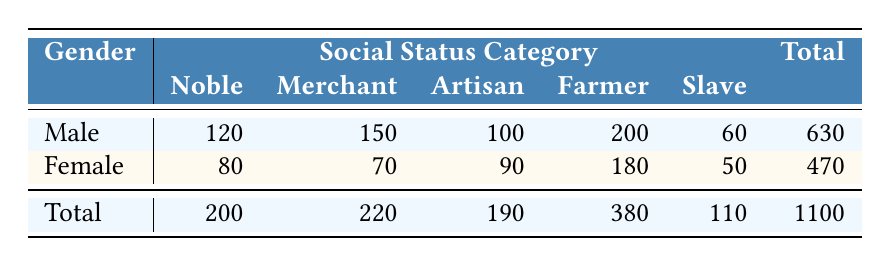What is the total count of nobles by gender? The table shows that there are 120 nobles who are male and 80 nobles who are female. Therefore, to find the total count of nobles, we sum these values: 120 + 80 = 200.
Answer: 200 How many male artisans are there compared to females? The table indicates that there are 100 male artisans and 90 female artisans. To find the difference, subtract the number of female artisans from male artisans: 100 - 90 = 10.
Answer: 10 What is the total count of farmers in the data? The table lists 200 male farmers and 180 female farmers. To find the total count of farmers, we add these numbers together: 200 + 180 = 380.
Answer: 380 Is it true that there are more male merchants than female merchants? According to the table, there are 150 male merchants and 70 female merchants. Since 150 is greater than 70, the statement is true.
Answer: Yes Which gender has a higher total social status count? Adding the counts for males: 120 (Noble) + 150 (Merchant) + 100 (Artisan) + 200 (Farmer) + 60 (Slave) = 630, and for females: 80 (Noble) + 70 (Merchant) + 90 (Artisan) + 180 (Farmer) + 50 (Slave) = 470. Since 630 is greater than 470, males have a higher total count.
Answer: Males What is the average count of slaves among both genders? The table shows 60 male slaves and 50 female slaves. First, we find the total number of slaves: 60 + 50 = 110. Next, to find the average, we divide this total by the number of genders (2): 110 / 2 = 55.
Answer: 55 What is the total count of artisans and how does it compare by gender? The table lists 100 male artisans and 90 female artisans. To find the total count of artisans, add these numbers: 100 + 90 = 190. The difference shows that there are 10 more male artisans than female artisans: 100 - 90 = 10.
Answer: 190 How many more noble males are there compared to noble females? From the table, there are 120 male nobles and 80 female nobles. To find the difference, subtract the number of female nobles from the number of male nobles: 120 - 80 = 40.
Answer: 40 What percentage of total individuals classified as farmers are female? There are a total of 380 farmers: 200 males and 180 females. The number of female farmers is 180. To find the percentage of female farmers, divide the number of female farmers by the total farmers and multiply by 100: (180 / 380) * 100 ≈ 47.37%.
Answer: Approximately 47.37% 